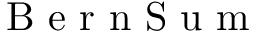<formula> <loc_0><loc_0><loc_500><loc_500>B e r n S u m</formula> 